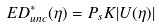<formula> <loc_0><loc_0><loc_500><loc_500>E D ^ { * } _ { u n c } ( \eta ) = P _ { s } K | U ( \eta ) |</formula> 